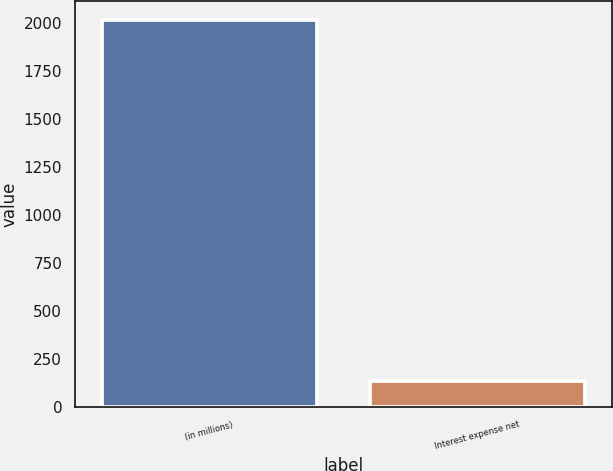Convert chart to OTSL. <chart><loc_0><loc_0><loc_500><loc_500><bar_chart><fcel>(in millions)<fcel>Interest expense net<nl><fcel>2014<fcel>133<nl></chart> 